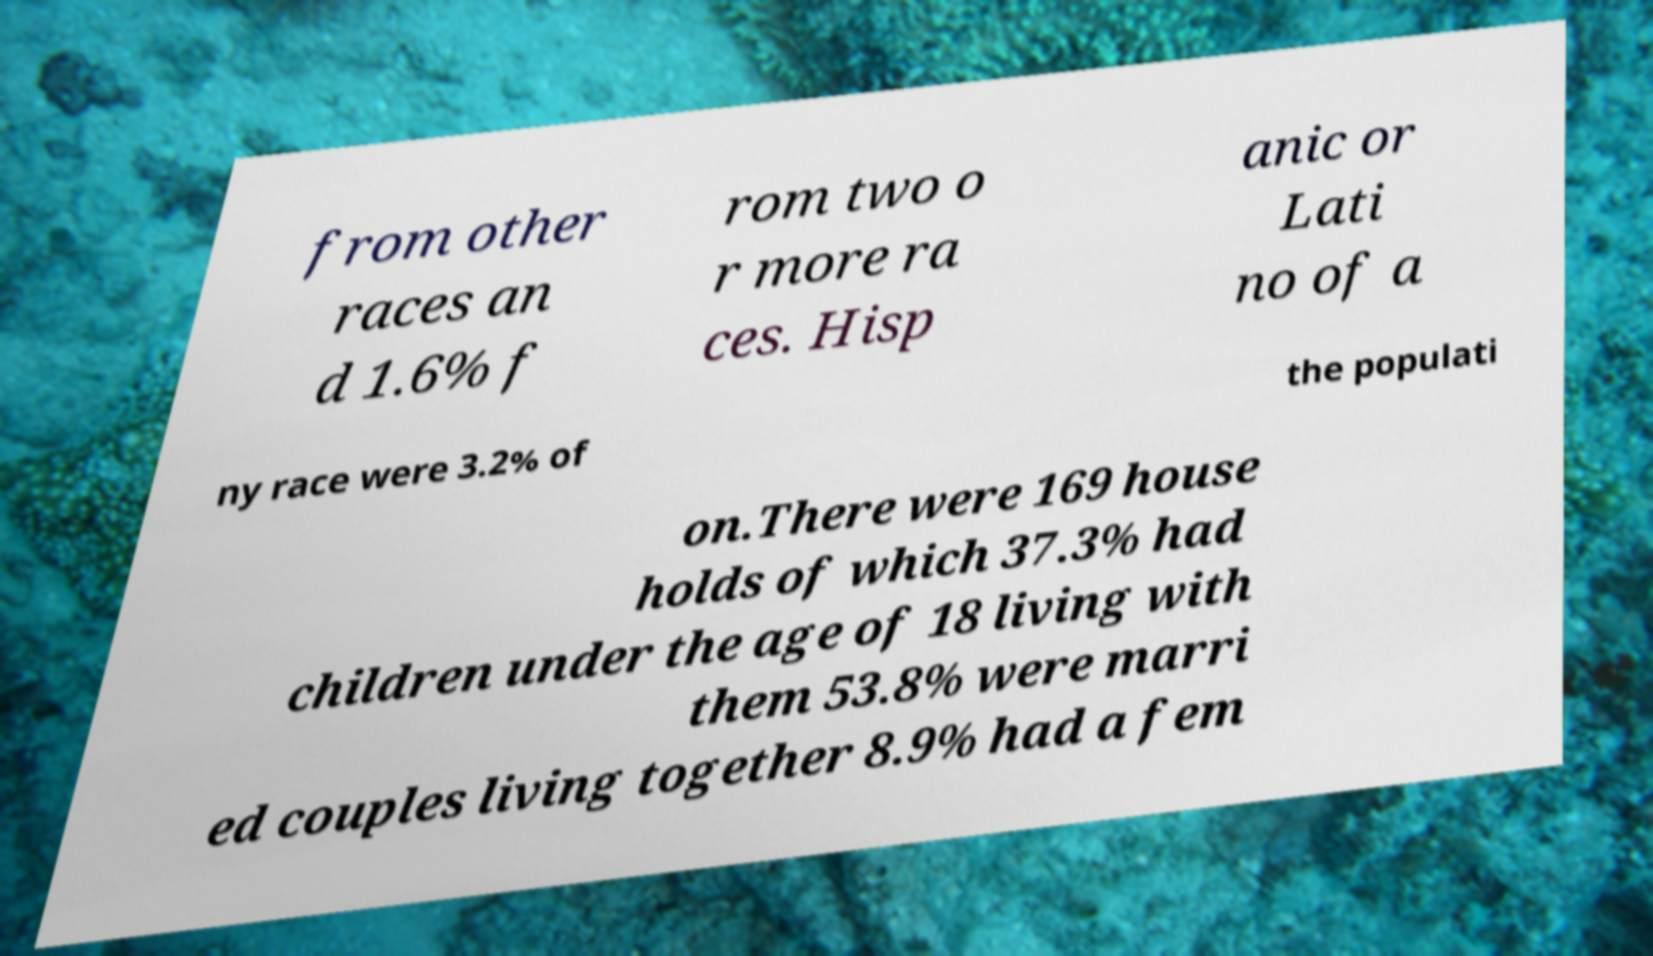For documentation purposes, I need the text within this image transcribed. Could you provide that? from other races an d 1.6% f rom two o r more ra ces. Hisp anic or Lati no of a ny race were 3.2% of the populati on.There were 169 house holds of which 37.3% had children under the age of 18 living with them 53.8% were marri ed couples living together 8.9% had a fem 